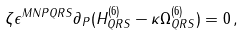<formula> <loc_0><loc_0><loc_500><loc_500>\zeta \epsilon ^ { M N P Q R S } \partial _ { P } ( H ^ { ( 6 ) } _ { Q R S } - \kappa \Omega ^ { ( 6 ) } _ { Q R S } ) = 0 \, ,</formula> 